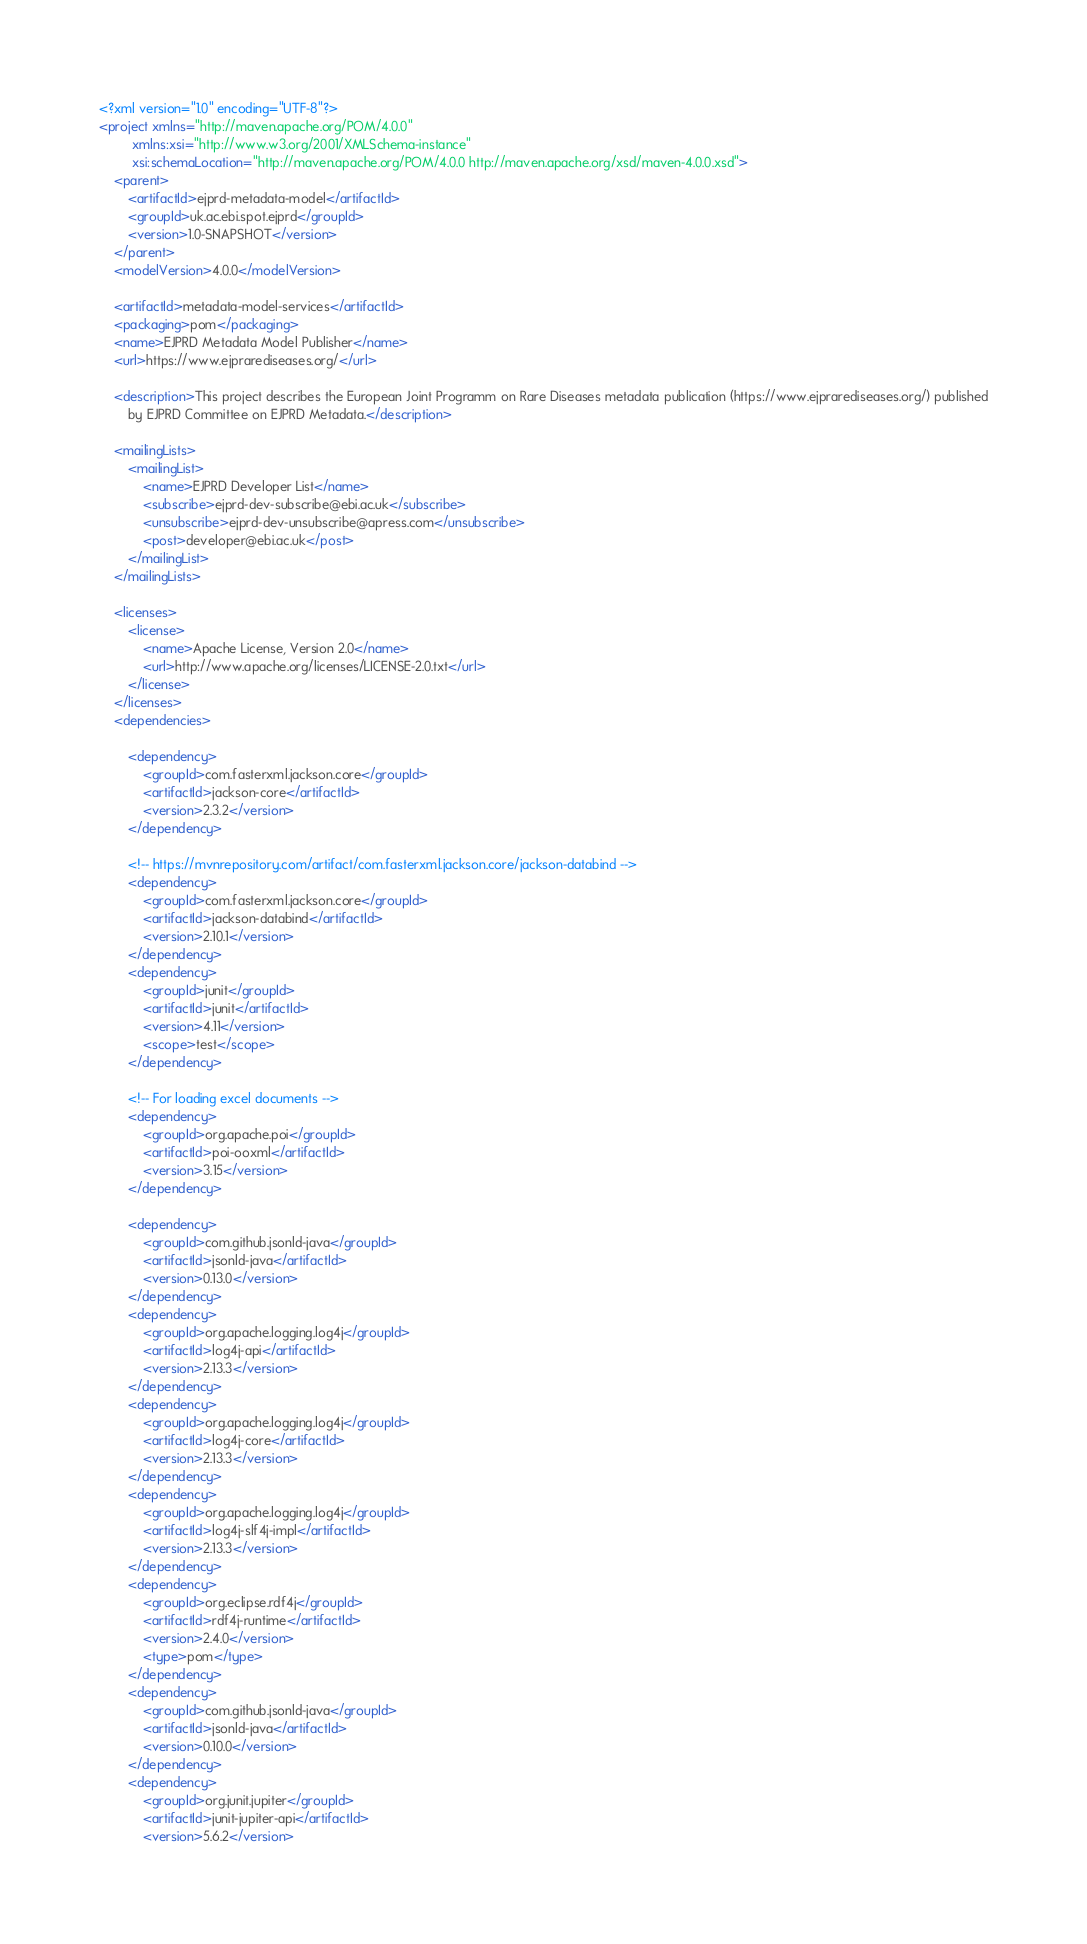<code> <loc_0><loc_0><loc_500><loc_500><_XML_><?xml version="1.0" encoding="UTF-8"?>
<project xmlns="http://maven.apache.org/POM/4.0.0"
         xmlns:xsi="http://www.w3.org/2001/XMLSchema-instance"
         xsi:schemaLocation="http://maven.apache.org/POM/4.0.0 http://maven.apache.org/xsd/maven-4.0.0.xsd">
    <parent>
        <artifactId>ejprd-metadata-model</artifactId>
        <groupId>uk.ac.ebi.spot.ejprd</groupId>
        <version>1.0-SNAPSHOT</version>
    </parent>
    <modelVersion>4.0.0</modelVersion>

    <artifactId>metadata-model-services</artifactId>
    <packaging>pom</packaging>
    <name>EJPRD Metadata Model Publisher</name>
    <url>https://www.ejprarediseases.org/</url>

    <description>This project describes the European Joint Programm on Rare Diseases metadata publication (https://www.ejprarediseases.org/) published
        by EJPRD Committee on EJPRD Metadata.</description>

    <mailingLists>
        <mailingList>
            <name>EJPRD Developer List</name>
            <subscribe>ejprd-dev-subscribe@ebi.ac.uk</subscribe>
            <unsubscribe>ejprd-dev-unsubscribe@apress.com</unsubscribe>
            <post>developer@ebi.ac.uk</post>
        </mailingList>
    </mailingLists>

    <licenses>
        <license>
            <name>Apache License, Version 2.0</name>
            <url>http://www.apache.org/licenses/LICENSE-2.0.txt</url>
        </license>
    </licenses>
    <dependencies>

        <dependency>
            <groupId>com.fasterxml.jackson.core</groupId>
            <artifactId>jackson-core</artifactId>
            <version>2.3.2</version>
        </dependency>

        <!-- https://mvnrepository.com/artifact/com.fasterxml.jackson.core/jackson-databind -->
        <dependency>
            <groupId>com.fasterxml.jackson.core</groupId>
            <artifactId>jackson-databind</artifactId>
            <version>2.10.1</version>
        </dependency>
        <dependency>
            <groupId>junit</groupId>
            <artifactId>junit</artifactId>
            <version>4.11</version>
            <scope>test</scope>
        </dependency>

        <!-- For loading excel documents -->
        <dependency>
            <groupId>org.apache.poi</groupId>
            <artifactId>poi-ooxml</artifactId>
            <version>3.15</version>
        </dependency>

        <dependency>
            <groupId>com.github.jsonld-java</groupId>
            <artifactId>jsonld-java</artifactId>
            <version>0.13.0</version>
        </dependency>
        <dependency>
            <groupId>org.apache.logging.log4j</groupId>
            <artifactId>log4j-api</artifactId>
            <version>2.13.3</version>
        </dependency>
        <dependency>
            <groupId>org.apache.logging.log4j</groupId>
            <artifactId>log4j-core</artifactId>
            <version>2.13.3</version>
        </dependency>
        <dependency>
            <groupId>org.apache.logging.log4j</groupId>
            <artifactId>log4j-slf4j-impl</artifactId>
            <version>2.13.3</version>
        </dependency>
        <dependency>
            <groupId>org.eclipse.rdf4j</groupId>
            <artifactId>rdf4j-runtime</artifactId>
            <version>2.4.0</version>
            <type>pom</type>
        </dependency>
        <dependency>
            <groupId>com.github.jsonld-java</groupId>
            <artifactId>jsonld-java</artifactId>
            <version>0.10.0</version>
        </dependency>
        <dependency>
            <groupId>org.junit.jupiter</groupId>
            <artifactId>junit-jupiter-api</artifactId>
            <version>5.6.2</version></code> 